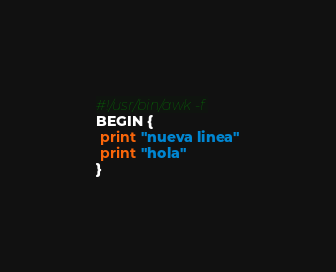Convert code to text. <code><loc_0><loc_0><loc_500><loc_500><_Awk_>#!/usr/bin/awk -f
BEGIN {
 print "nueva linea"
 print "hola"
}
</code> 